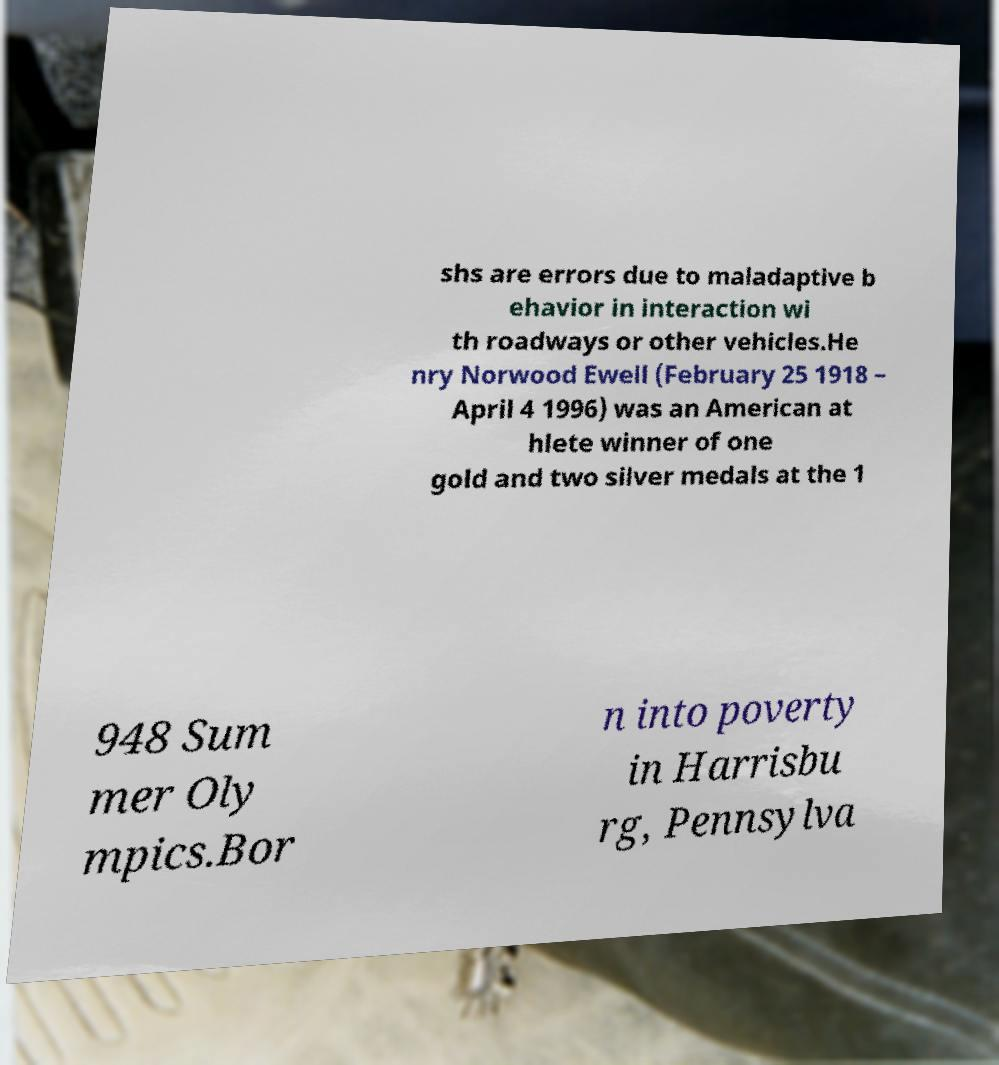Can you accurately transcribe the text from the provided image for me? shs are errors due to maladaptive b ehavior in interaction wi th roadways or other vehicles.He nry Norwood Ewell (February 25 1918 – April 4 1996) was an American at hlete winner of one gold and two silver medals at the 1 948 Sum mer Oly mpics.Bor n into poverty in Harrisbu rg, Pennsylva 